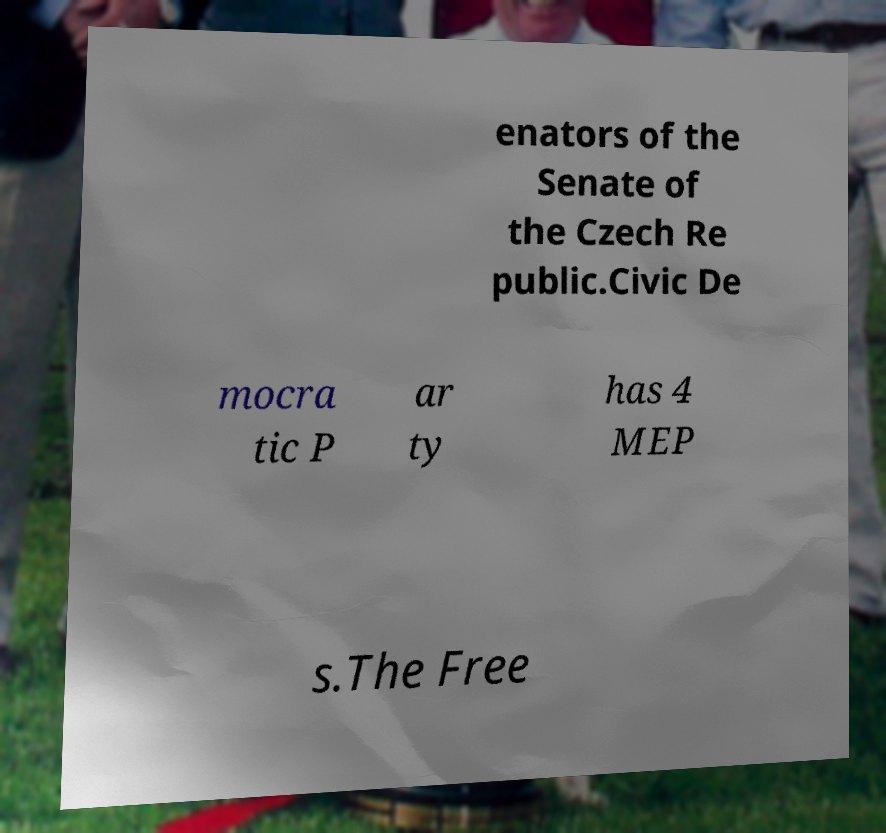Can you accurately transcribe the text from the provided image for me? enators of the Senate of the Czech Re public.Civic De mocra tic P ar ty has 4 MEP s.The Free 